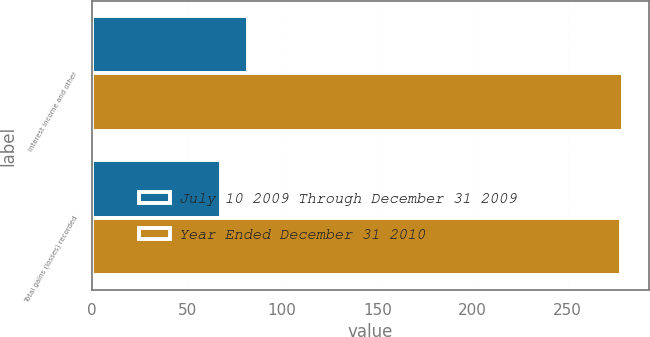Convert chart to OTSL. <chart><loc_0><loc_0><loc_500><loc_500><stacked_bar_chart><ecel><fcel>Interest income and other<fcel>Total gains (losses) recorded<nl><fcel>July 10 2009 Through December 31 2009<fcel>82<fcel>68<nl><fcel>Year Ended December 31 2010<fcel>279<fcel>278<nl></chart> 